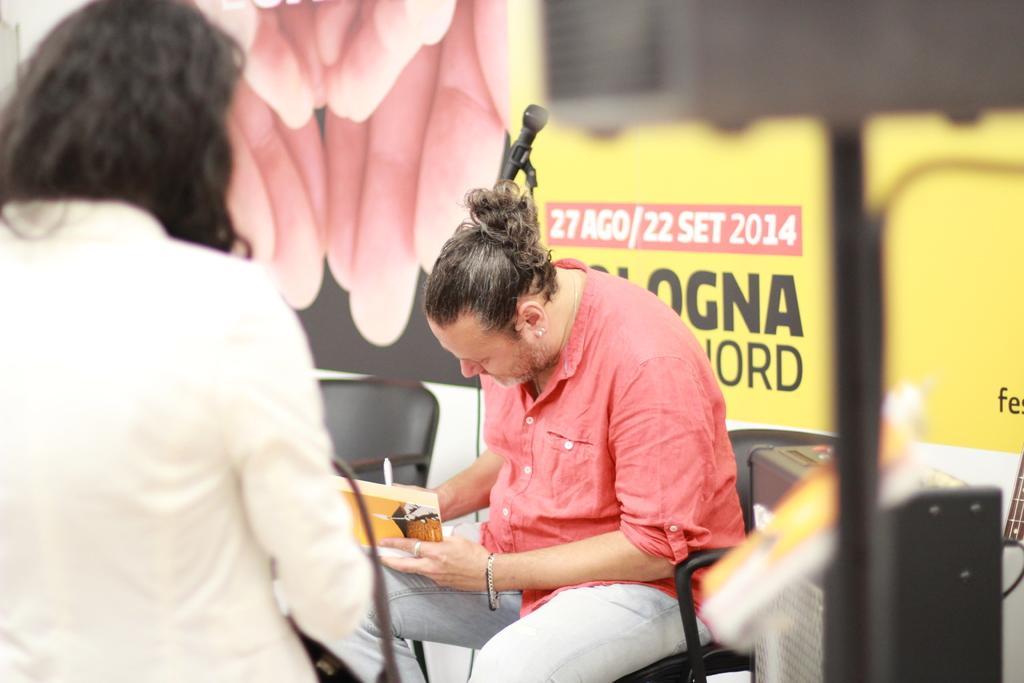Could you give a brief overview of what you see in this image? In the image we can see there are two people wearing clothes. One person is sitting and the other one is standing. Here we can see the person wearing the bracelet, earrings, finger ring and holding a book in hand. Here we can see microphone, poster, sound box and chairs. 